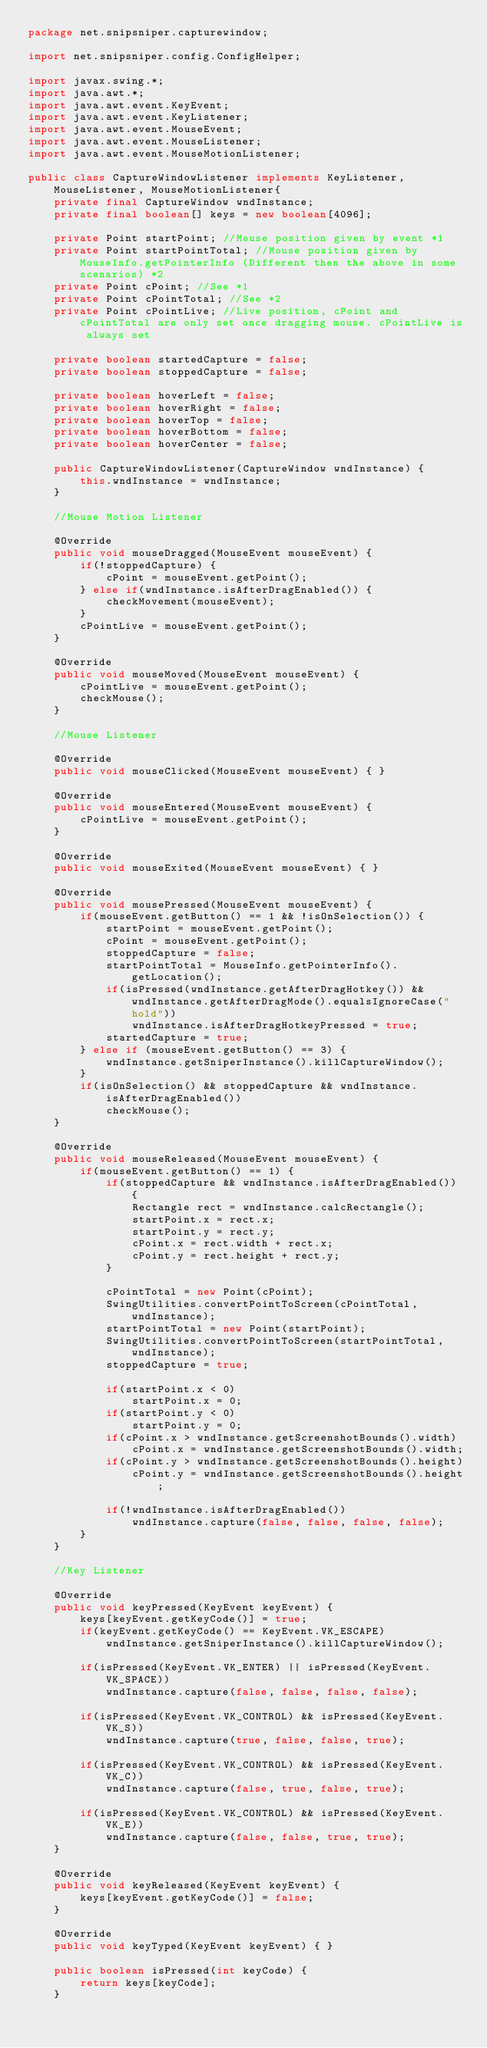Convert code to text. <code><loc_0><loc_0><loc_500><loc_500><_Java_>package net.snipsniper.capturewindow;

import net.snipsniper.config.ConfigHelper;

import javax.swing.*;
import java.awt.*;
import java.awt.event.KeyEvent;
import java.awt.event.KeyListener;
import java.awt.event.MouseEvent;
import java.awt.event.MouseListener;
import java.awt.event.MouseMotionListener;

public class CaptureWindowListener implements KeyListener, MouseListener, MouseMotionListener{
	private final CaptureWindow wndInstance;
	private final boolean[] keys = new boolean[4096];

	private Point startPoint; //Mouse position given by event *1
	private Point startPointTotal; //Mouse position given by MouseInfo.getPointerInfo (Different then the above in some scenarios) *2
	private Point cPoint; //See *1
	private Point cPointTotal; //See *2
	private Point cPointLive; //Live position, cPoint and cPointTotal are only set once dragging mouse. cPointLive is always set

	private boolean startedCapture = false;
	private boolean stoppedCapture = false;

	private boolean hoverLeft = false;
	private boolean hoverRight = false;
	private boolean hoverTop = false;
	private boolean hoverBottom = false;
	private boolean hoverCenter = false;

	public CaptureWindowListener(CaptureWindow wndInstance) {
		this.wndInstance = wndInstance;
	}

	//Mouse Motion Listener

	@Override
	public void mouseDragged(MouseEvent mouseEvent) {
		if(!stoppedCapture) {
			cPoint = mouseEvent.getPoint();
		} else if(wndInstance.isAfterDragEnabled()) {
			checkMovement(mouseEvent);
		}
		cPointLive = mouseEvent.getPoint();
	}
	
	@Override
	public void mouseMoved(MouseEvent mouseEvent) {
		cPointLive = mouseEvent.getPoint();
		checkMouse();
	}

	//Mouse Listener

	@Override
	public void mouseClicked(MouseEvent mouseEvent) { }
	
	@Override
	public void mouseEntered(MouseEvent mouseEvent) {
		cPointLive = mouseEvent.getPoint();
	}

	@Override
	public void mouseExited(MouseEvent mouseEvent) { }

	@Override
	public void mousePressed(MouseEvent mouseEvent) {
		if(mouseEvent.getButton() == 1 && !isOnSelection()) {
			startPoint = mouseEvent.getPoint();
			cPoint = mouseEvent.getPoint();
			stoppedCapture = false;
			startPointTotal = MouseInfo.getPointerInfo().getLocation();
			if(isPressed(wndInstance.getAfterDragHotkey()) && wndInstance.getAfterDragMode().equalsIgnoreCase("hold"))
				wndInstance.isAfterDragHotkeyPressed = true;
			startedCapture = true;
		} else if (mouseEvent.getButton() == 3) {
			wndInstance.getSniperInstance().killCaptureWindow();
		}
		if(isOnSelection() && stoppedCapture && wndInstance.isAfterDragEnabled())
			checkMouse();
	}

	@Override
	public void mouseReleased(MouseEvent mouseEvent) {
		if(mouseEvent.getButton() == 1) {
			if(stoppedCapture && wndInstance.isAfterDragEnabled()) {
				Rectangle rect = wndInstance.calcRectangle();
				startPoint.x = rect.x;
				startPoint.y = rect.y;
				cPoint.x = rect.width + rect.x;
				cPoint.y = rect.height + rect.y;
			}

			cPointTotal = new Point(cPoint);
			SwingUtilities.convertPointToScreen(cPointTotal, wndInstance);
			startPointTotal = new Point(startPoint);
			SwingUtilities.convertPointToScreen(startPointTotal, wndInstance);
			stoppedCapture = true;

			if(startPoint.x < 0)
				startPoint.x = 0;
			if(startPoint.y < 0)
				startPoint.y = 0;
			if(cPoint.x > wndInstance.getScreenshotBounds().width)
				cPoint.x = wndInstance.getScreenshotBounds().width;
			if(cPoint.y > wndInstance.getScreenshotBounds().height)
				cPoint.y = wndInstance.getScreenshotBounds().height;

			if(!wndInstance.isAfterDragEnabled())
				wndInstance.capture(false, false, false, false);
		}
	}
	
	//Key Listener
	
	@Override
	public void keyPressed(KeyEvent keyEvent) {
		keys[keyEvent.getKeyCode()] = true;
		if(keyEvent.getKeyCode() == KeyEvent.VK_ESCAPE)
			wndInstance.getSniperInstance().killCaptureWindow();

		if(isPressed(KeyEvent.VK_ENTER) || isPressed(KeyEvent.VK_SPACE))
			wndInstance.capture(false, false, false, false);

		if(isPressed(KeyEvent.VK_CONTROL) && isPressed(KeyEvent.VK_S))
			wndInstance.capture(true, false, false, true);

		if(isPressed(KeyEvent.VK_CONTROL) && isPressed(KeyEvent.VK_C))
			wndInstance.capture(false, true, false, true);

		if(isPressed(KeyEvent.VK_CONTROL) && isPressed(KeyEvent.VK_E))
			wndInstance.capture(false, false, true, true);
	}

	@Override
	public void keyReleased(KeyEvent keyEvent) {
		keys[keyEvent.getKeyCode()] = false;
	}

	@Override
	public void keyTyped(KeyEvent keyEvent) { }

	public boolean isPressed(int keyCode) {
		return keys[keyCode];
	}
</code> 